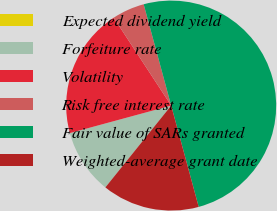Convert chart. <chart><loc_0><loc_0><loc_500><loc_500><pie_chart><fcel>Expected dividend yield<fcel>Forfeiture rate<fcel>Volatility<fcel>Risk free interest rate<fcel>Fair value of SARs granted<fcel>Weighted-average grant date<nl><fcel>0.0%<fcel>10.0%<fcel>20.0%<fcel>5.0%<fcel>50.0%<fcel>15.0%<nl></chart> 